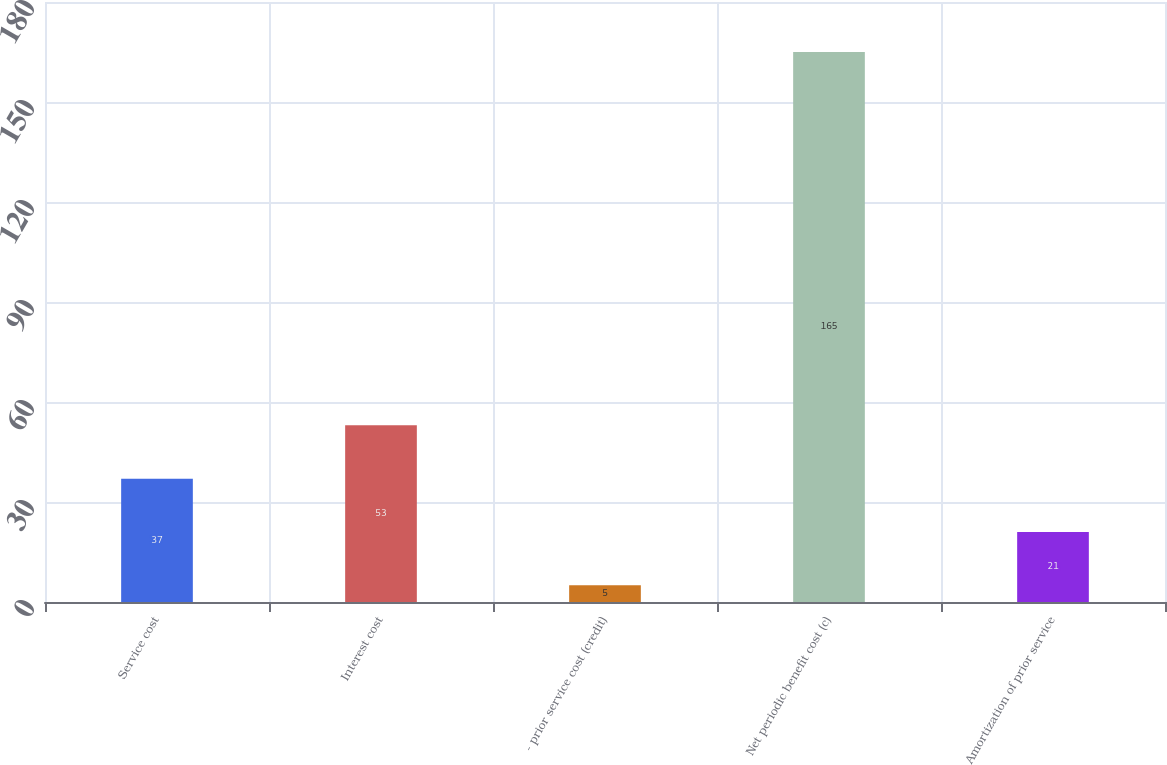<chart> <loc_0><loc_0><loc_500><loc_500><bar_chart><fcel>Service cost<fcel>Interest cost<fcel>- prior service cost (credit)<fcel>Net periodic benefit cost (c)<fcel>Amortization of prior service<nl><fcel>37<fcel>53<fcel>5<fcel>165<fcel>21<nl></chart> 